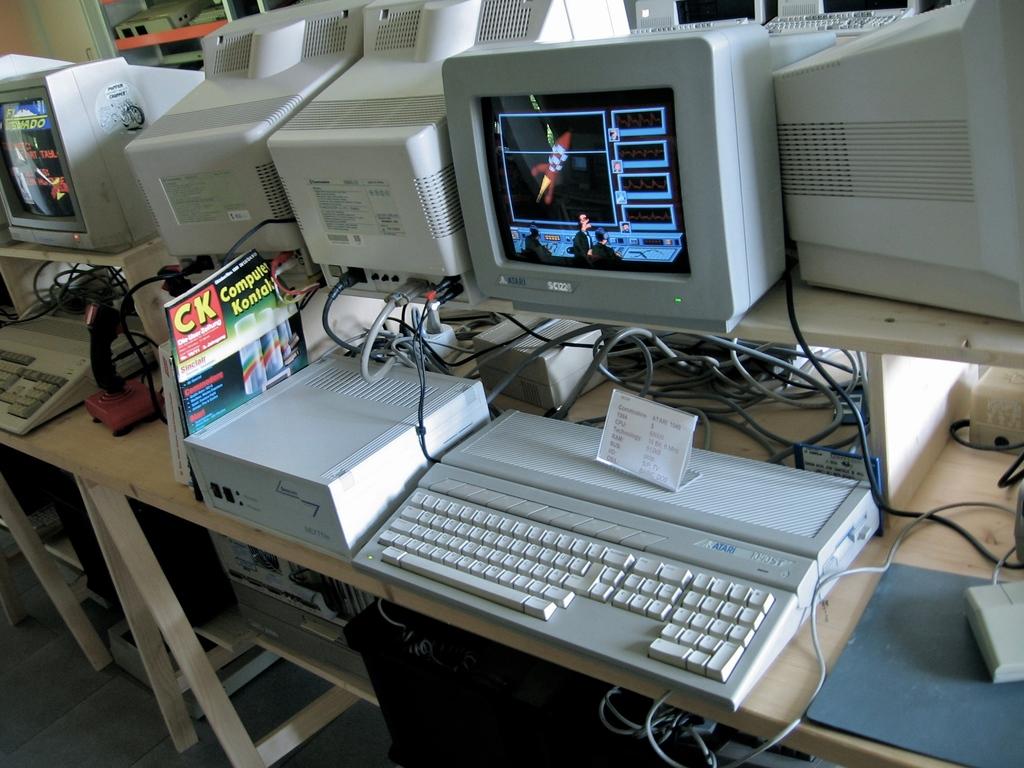What brand of keyboard is shown?
Your response must be concise. Atari. What are the large yellow letters on the red background?
Ensure brevity in your answer.  Ck. 